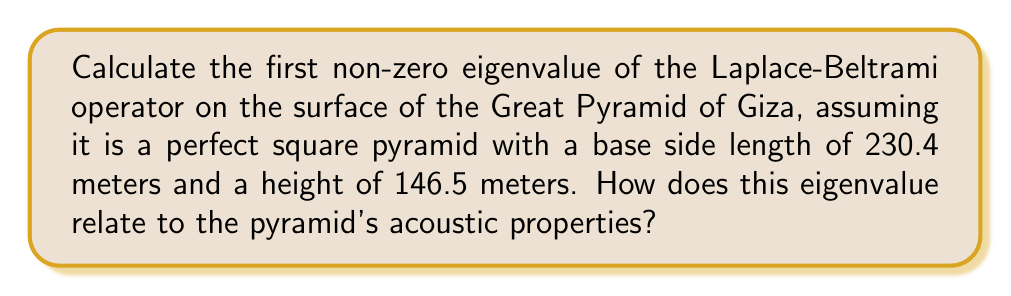Show me your answer to this math problem. To solve this problem, we'll follow these steps:

1) First, we need to understand the geometry of the Great Pyramid. It's a square pyramid with:
   Base side length: $a = 230.4$ m
   Height: $h = 146.5$ m

2) The surface area of the pyramid (excluding the base) is given by:
   $$A = 2a\sqrt{\frac{a^2}{4} + h^2}$$

3) Substituting the values:
   $$A = 2(230.4)\sqrt{\frac{230.4^2}{4} + 146.5^2} = 188,243.2 \text{ m}^2$$

4) For a pyramid surface, the first non-zero eigenvalue of the Laplace-Beltrami operator can be approximated using the formula:
   $$\lambda_1 \approx \frac{4\pi^2}{A}$$

5) Substituting our calculated surface area:
   $$\lambda_1 \approx \frac{4\pi^2}{188,243.2} = 0.000264 \text{ m}^{-2}$$

6) The eigenvalue is related to the fundamental frequency of vibration of the pyramid's surface. The frequency $f$ is given by:
   $$f = \frac{\sqrt{\lambda_1}}{2\pi}\sqrt{\frac{T}{\rho}}$$
   where $T$ is the surface tension and $\rho$ is the surface density.

7) This fundamental frequency would be one of the dominant frequencies in the acoustic response of the pyramid, influencing how sound waves interact with and reflect off its surface.
Answer: $\lambda_1 \approx 0.000264 \text{ m}^{-2}$; relates to fundamental vibration frequency 